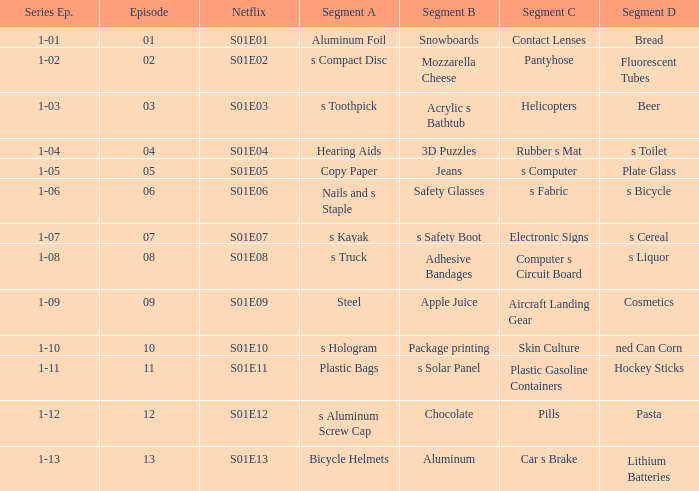What is the Netflix number having a segment of C of pills? S01E12. 